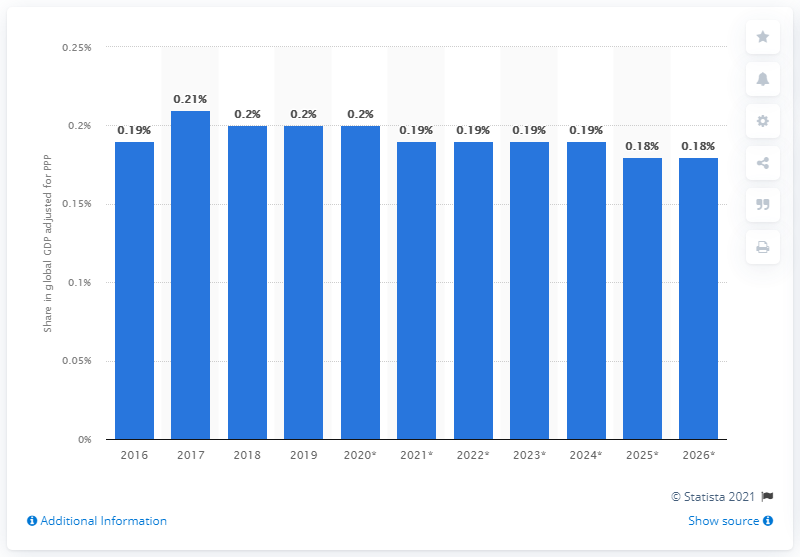Specify some key components in this picture. According to the data, Qatar's share in the global gross domestic product adjusted for Purchasing Power Parity in 2019 was 0.2%. According to estimates, Qatar's share in the global gross domestic product (GDP) adjusted for Purchasing Power Parity (PPP) is expected to end in 2026. 